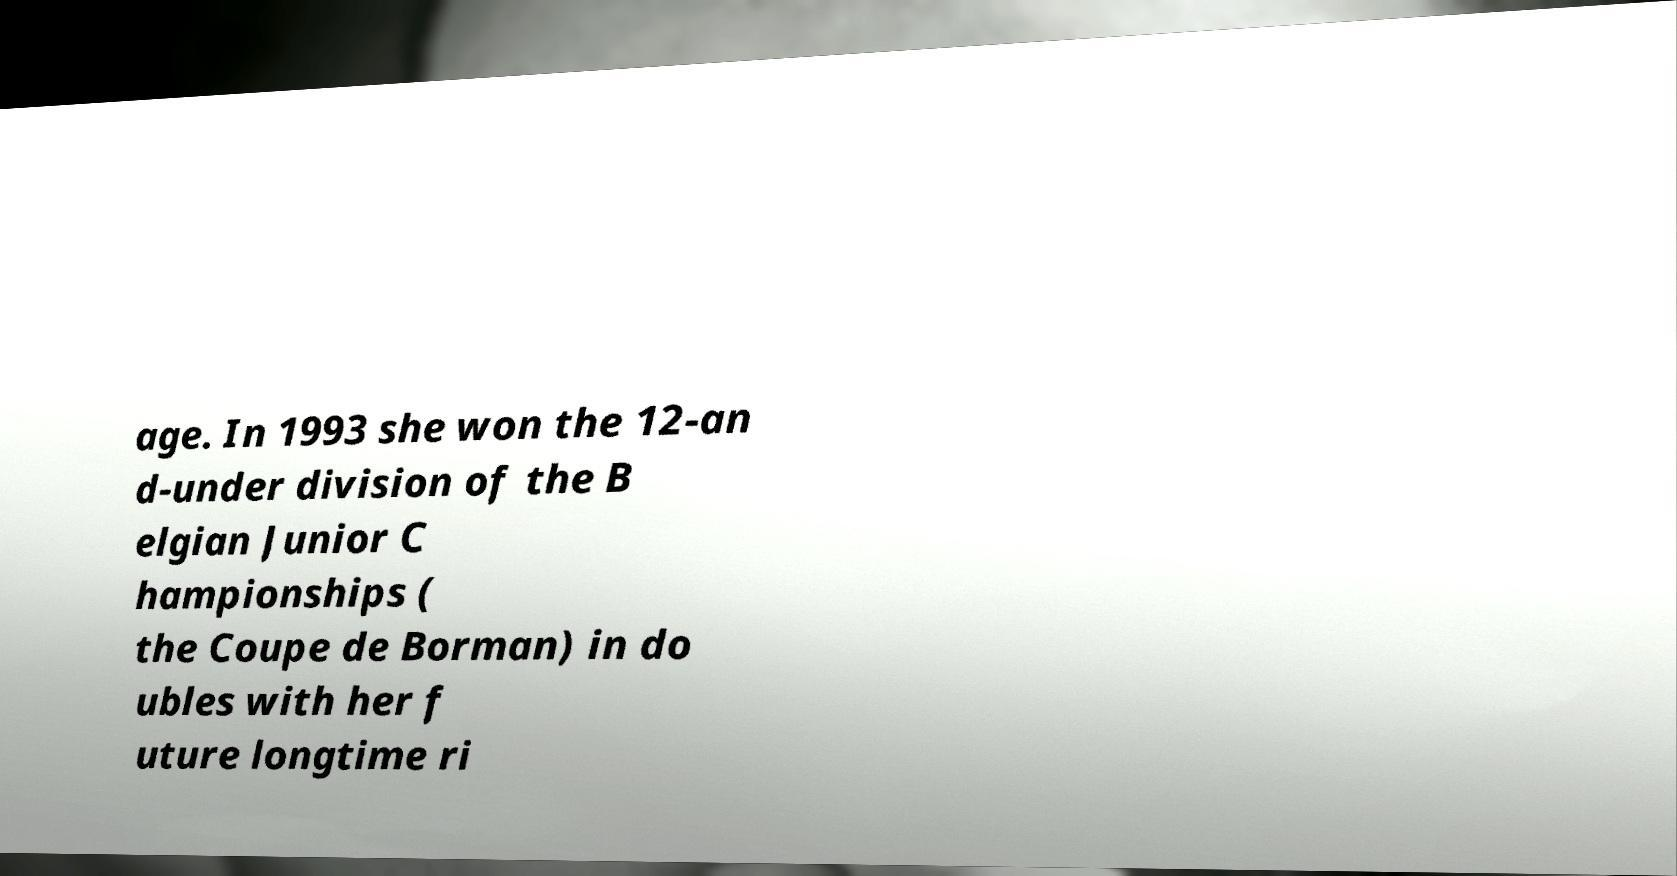I need the written content from this picture converted into text. Can you do that? age. In 1993 she won the 12-an d-under division of the B elgian Junior C hampionships ( the Coupe de Borman) in do ubles with her f uture longtime ri 